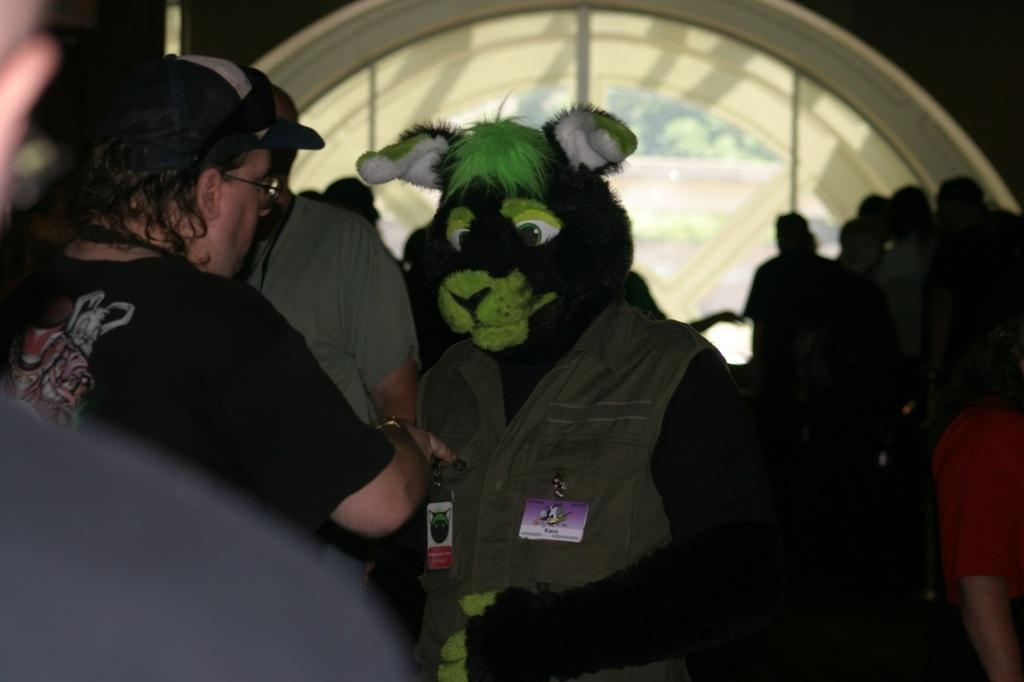Who is the main subject in the middle of the image? There is a man in the middle of the image. What is the man wearing on his face? The man is wearing an animal mask. Where are the people located on the left side of the image? There are people on the left side of the image. Can you describe the people in the background on the right side of the image? There are people in the background on the right side of the image. What type of toy can be seen in the image? There is no toy present in the image. Can you describe the flame coming from the bottle in the image? There is no bottle or flame present in the image. 